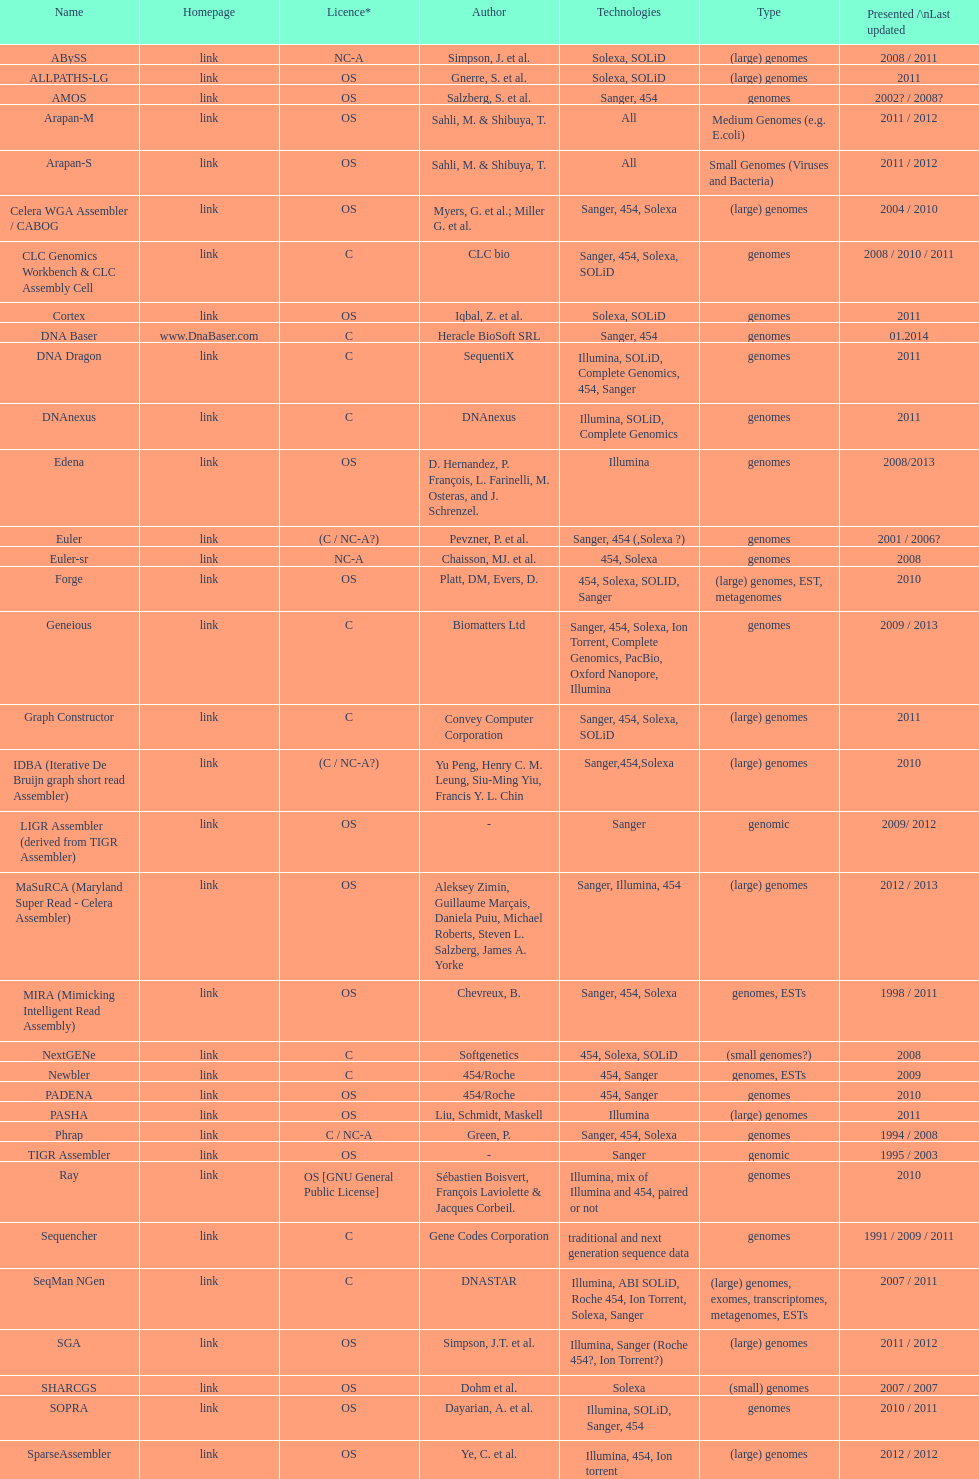What is the aggregate amount of assemblers for medium genome type technologies? 1. 